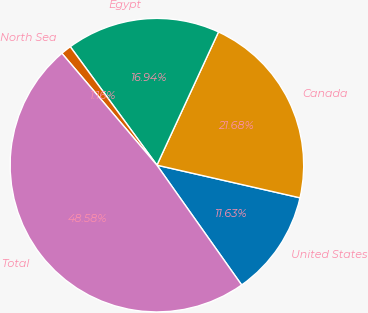<chart> <loc_0><loc_0><loc_500><loc_500><pie_chart><fcel>United States<fcel>Canada<fcel>Egypt<fcel>North Sea<fcel>Total<nl><fcel>11.63%<fcel>21.68%<fcel>16.94%<fcel>1.16%<fcel>48.58%<nl></chart> 